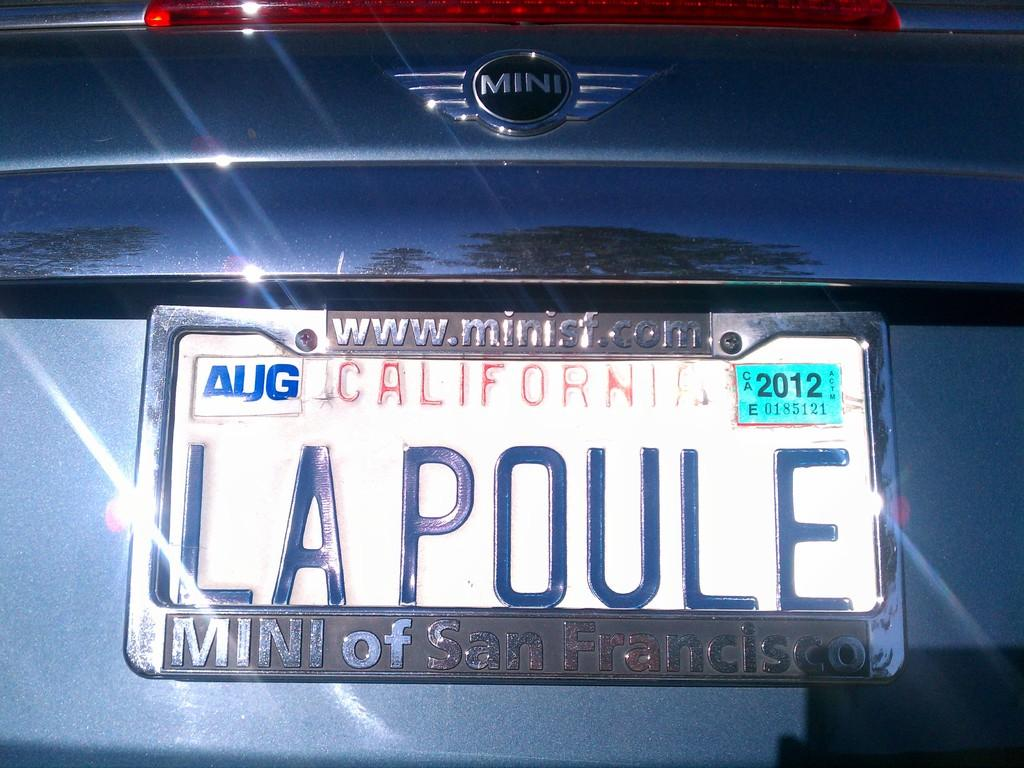<image>
Create a compact narrative representing the image presented. A blue Mini cooper with a California license plate. 